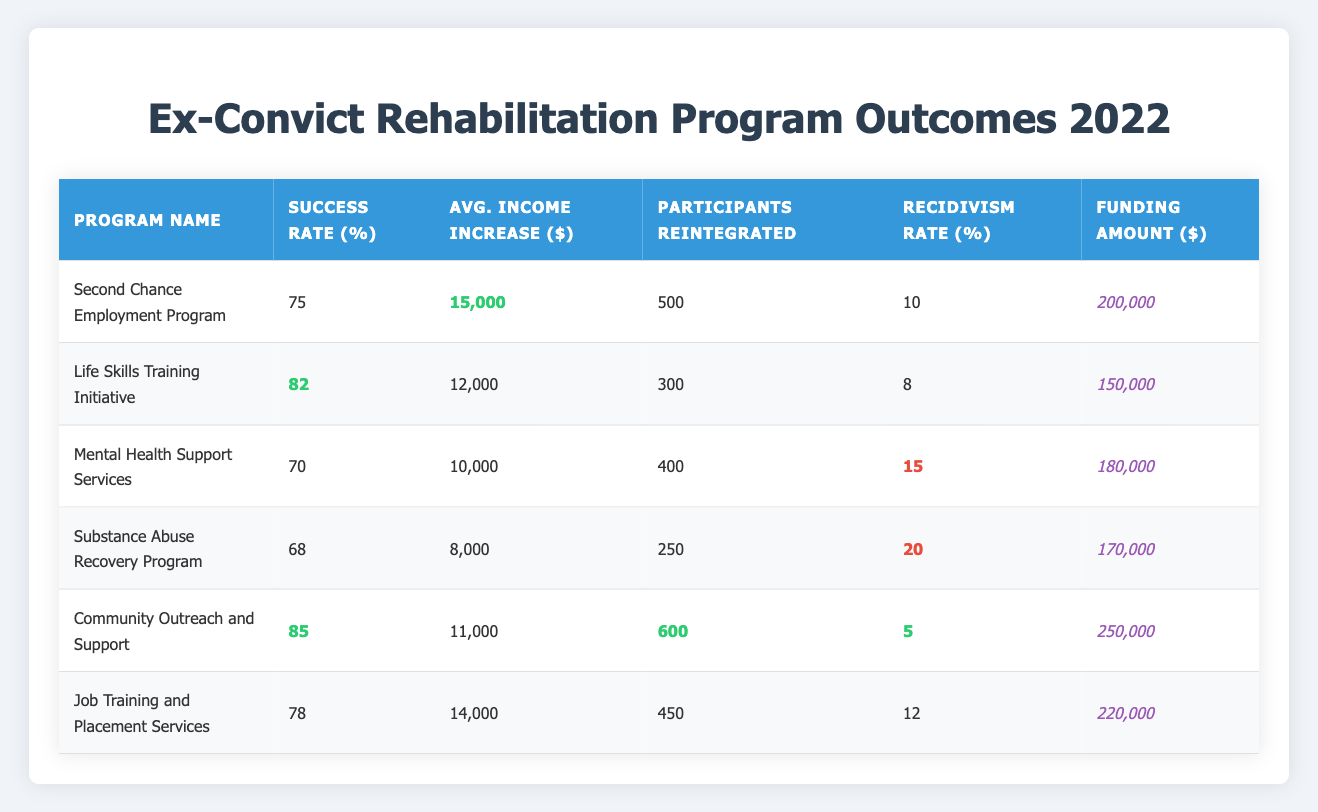What is the success rate of the Community Outreach and Support program? The success rate for this program is explicitly listed in the table as 85%.
Answer: 85% How many participants were reintegrated by the Mental Health Support Services program? The number of participants reintegrated by this program is shown in the table as 400.
Answer: 400 Which program had the highest average income increase? By comparing the average income increases in the table, the Second Chance Employment Program has the highest value at $15,000.
Answer: $15,000 What is the recidivism rate for the Substance Abuse Recovery Program? The recidivism rate is reported in the table as 20% for this program.
Answer: 20% Which program had the least participants reintegrated? Looking at the values in the "Participants Reintegrated" column, the Substance Abuse Recovery Program had the least participants at 250.
Answer: 250 What is the total funding amount for all the programs listed? Summing the funding amounts: $200,000 + $150,000 + $180,000 + $170,000 + $250,000 + $220,000 = $1,170,000 gives the total funding amount.
Answer: $1,170,000 What is the average success rate of the programs? The success rates are 75, 82, 70, 68, 85, and 78. Adding them results in 458; dividing by the number of programs (6) gives an average of 76.33.
Answer: 76.33 Is the success rate of the Life Skills Training Initiative above or below 80%? The success rate is 82%, which is clearly above 80% as indicated in the table.
Answer: Above Which program had the highest funding amount and what was that amount? The Community Outreach and Support program had the highest funding amount of $250,000 as listed in the table.
Answer: $250,000 Was the average income increase for the Job Training and Placement Services program greater than $13,000? The average income increase is $14,000, which is greater than $13,000 according to the table.
Answer: Yes How does the recidivism rate of the Life Skills Training Initiative compare to that of the Substance Abuse Recovery Program? The Life Skills Training Initiative has a recidivism rate of 8%, while the Substance Abuse Recovery Program has a rate of 20%, meaning the former has a lower (and thus more favorable) rate.
Answer: Lower Which program had both the highest success rate and lowest recidivism rate? The Community Outreach and Support program had the highest success rate of 85% and also the lowest recidivism rate of 5%, making it the most effective in both metrics.
Answer: Community Outreach and Support 